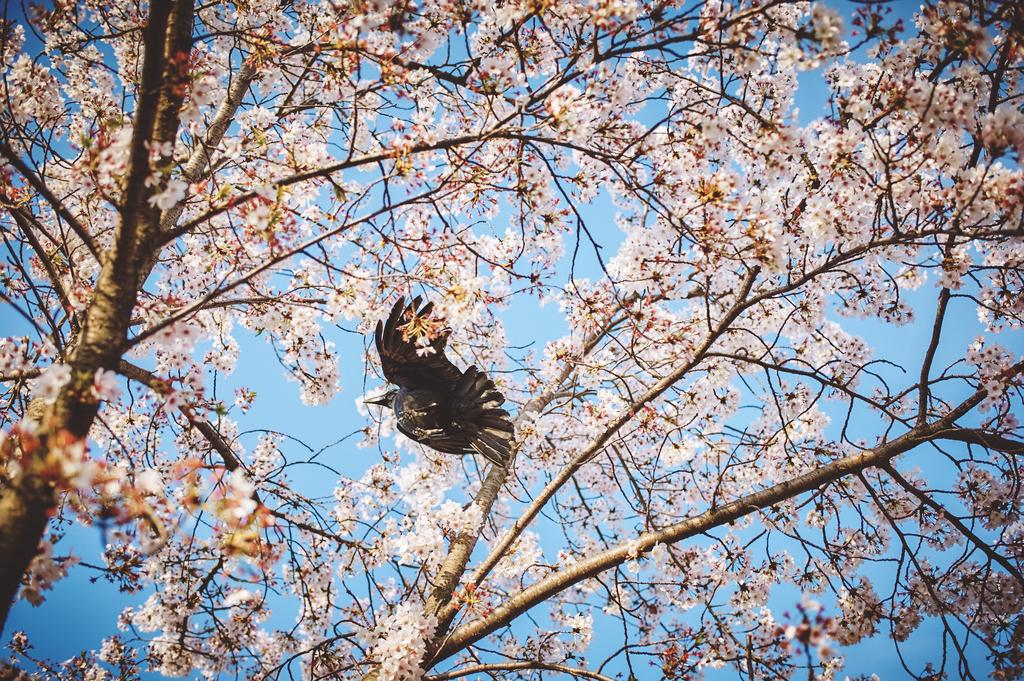What type of animal can be seen in the image? There is a bird in the image. Where is the bird located? The bird is standing on a tree. What is special about the tree in the image? The tree has pink flowers. What can be seen above the bird in the image? The sky is visible above the bird. How many eyes does the bird have on the tree? The bird has two eyes, but the question is unnecessary as the number of eyes is not relevant to the image. 